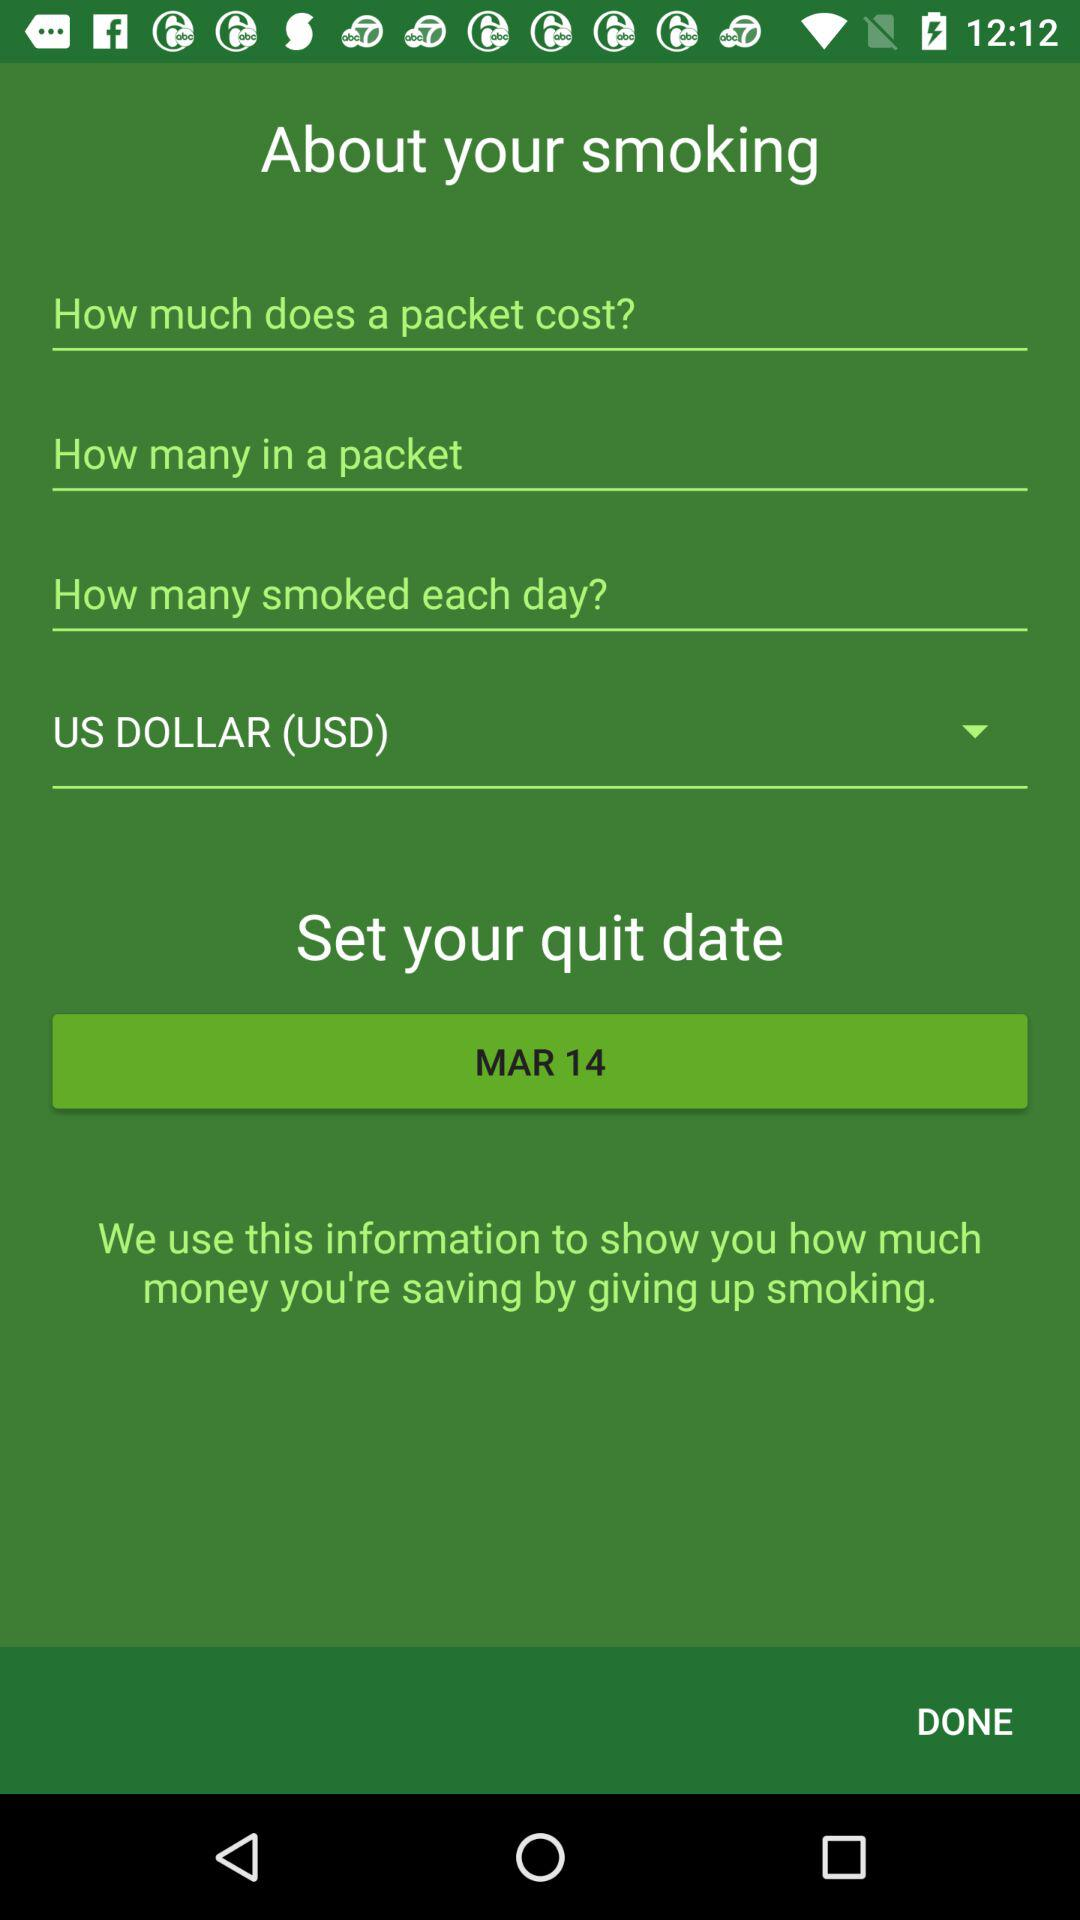What's the set quit date? The set quit date is March 14. 